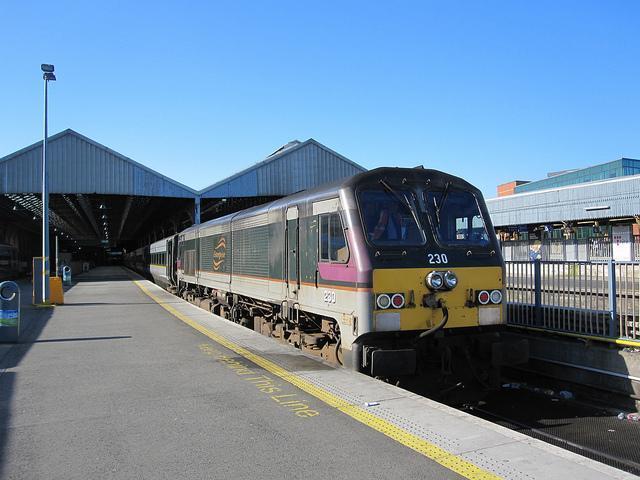How many zebras are there?
Give a very brief answer. 0. 